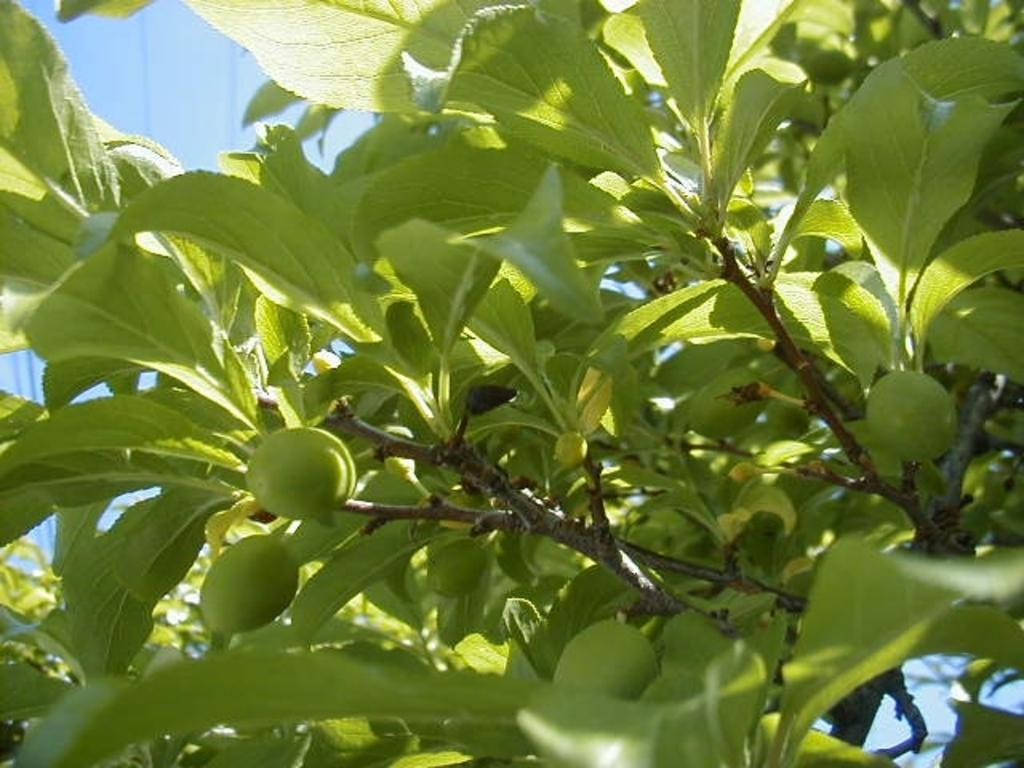What is present in the picture? There is a tree in the picture. Can you describe the tree's appearance? The tree has green leaves. Are there any fruits on the tree? Yes, the tree has fruits on it. What type of brick is being distributed in the afternoon in the image? There is no brick or distribution activity present in the image; it features a tree with green leaves and fruits. 